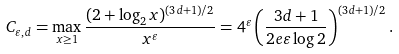Convert formula to latex. <formula><loc_0><loc_0><loc_500><loc_500>C _ { \varepsilon , d } = \max _ { x \geq 1 } \frac { ( 2 + \log _ { 2 } x ) ^ { ( 3 d + 1 ) / 2 } } { x ^ { \varepsilon } } = 4 ^ { \varepsilon } \left ( \frac { 3 d + 1 } { 2 e \varepsilon \log 2 } \right ) ^ { ( 3 d + 1 ) / 2 } .</formula> 